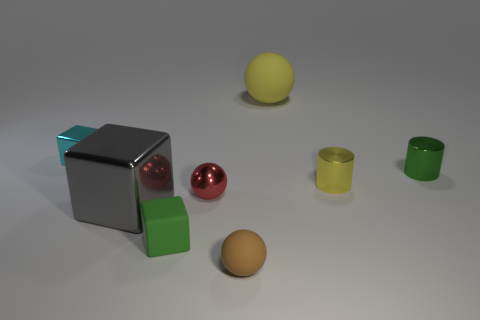Are there more large things that are in front of the large yellow rubber thing than small gray cubes?
Offer a very short reply. Yes. What color is the thing that is the same size as the gray metallic block?
Your answer should be very brief. Yellow. How many objects are either things in front of the cyan metal block or tiny red metallic balls?
Provide a succinct answer. 6. The other object that is the same color as the big rubber object is what shape?
Offer a terse response. Cylinder. There is a big object that is behind the green object that is to the right of the small brown ball; what is its material?
Offer a terse response. Rubber. Is there a tiny yellow cylinder that has the same material as the small red thing?
Ensure brevity in your answer.  Yes. Is there a brown rubber sphere that is behind the metallic cube behind the green metal cylinder?
Your answer should be very brief. No. There is a tiny cube in front of the small red metal thing; what is it made of?
Offer a very short reply. Rubber. Is the shape of the red thing the same as the large matte object?
Give a very brief answer. Yes. What is the color of the tiny matte thing that is in front of the green thing left of the yellow rubber ball behind the tiny yellow metal thing?
Give a very brief answer. Brown. 